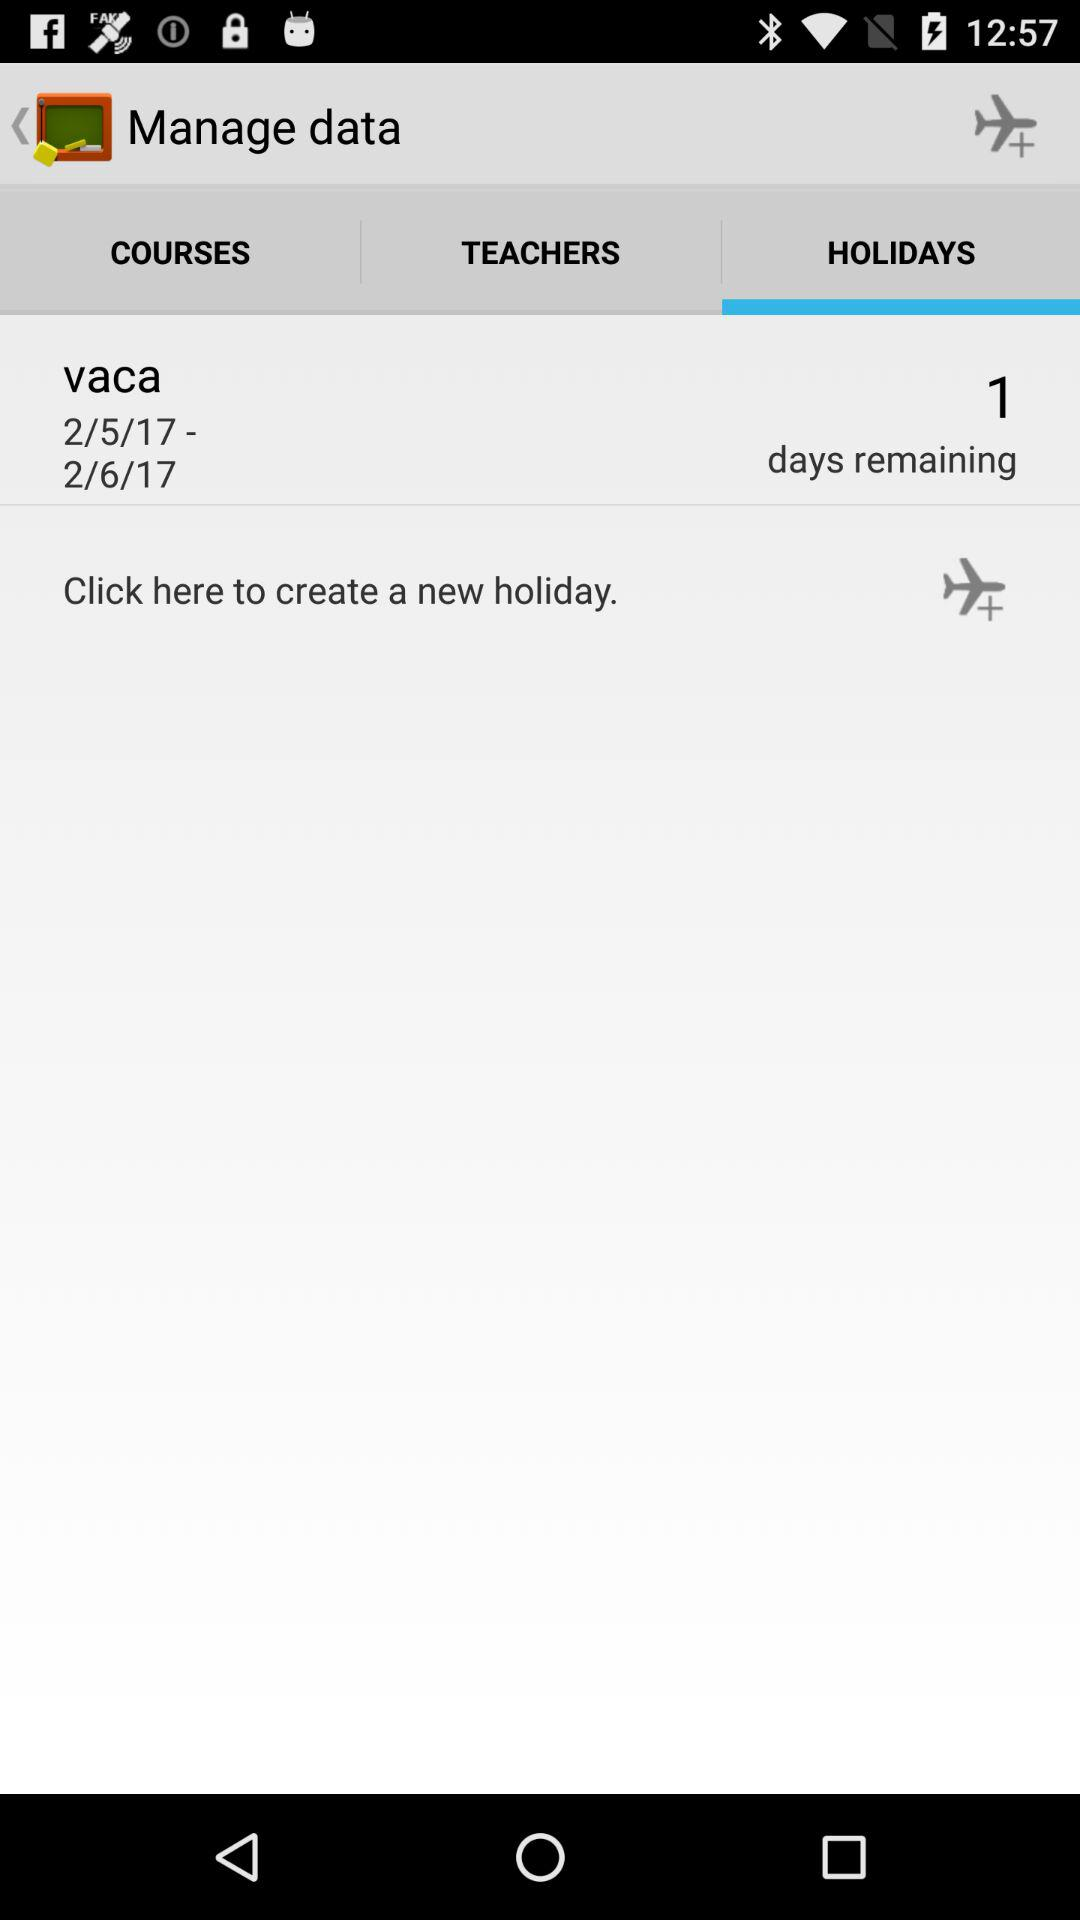How many days are remaining? There is only one day remaining. 